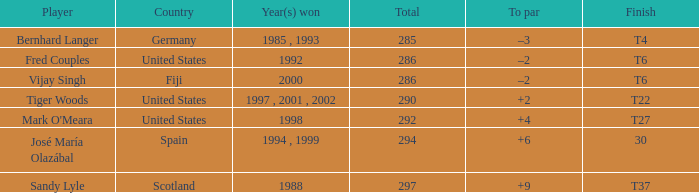What is the total of Mark O'meara? 292.0. I'm looking to parse the entire table for insights. Could you assist me with that? {'header': ['Player', 'Country', 'Year(s) won', 'Total', 'To par', 'Finish'], 'rows': [['Bernhard Langer', 'Germany', '1985 , 1993', '285', '–3', 'T4'], ['Fred Couples', 'United States', '1992', '286', '–2', 'T6'], ['Vijay Singh', 'Fiji', '2000', '286', '–2', 'T6'], ['Tiger Woods', 'United States', '1997 , 2001 , 2002', '290', '+2', 'T22'], ["Mark O'Meara", 'United States', '1998', '292', '+4', 'T27'], ['José María Olazábal', 'Spain', '1994 , 1999', '294', '+6', '30'], ['Sandy Lyle', 'Scotland', '1988', '297', '+9', 'T37']]} 